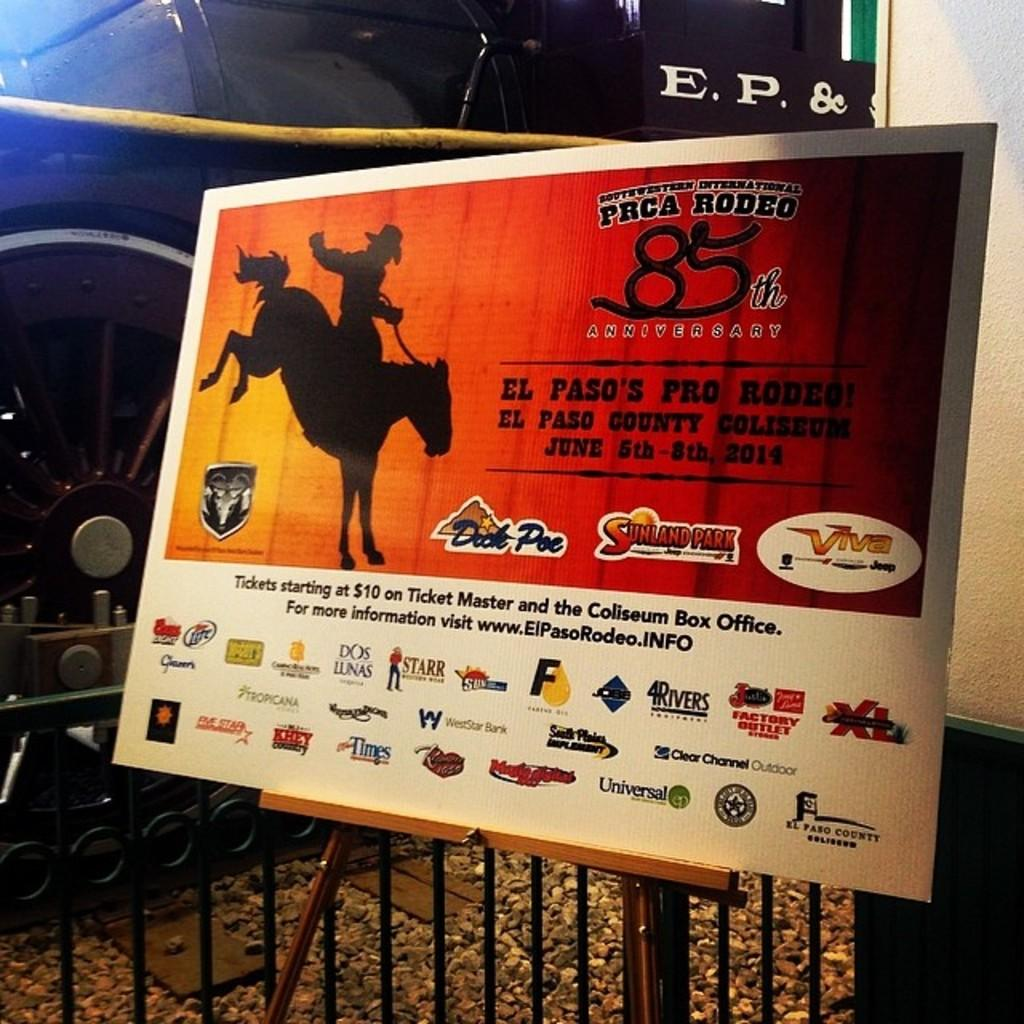<image>
Relay a brief, clear account of the picture shown. a rodeo message with the number 85 on it 